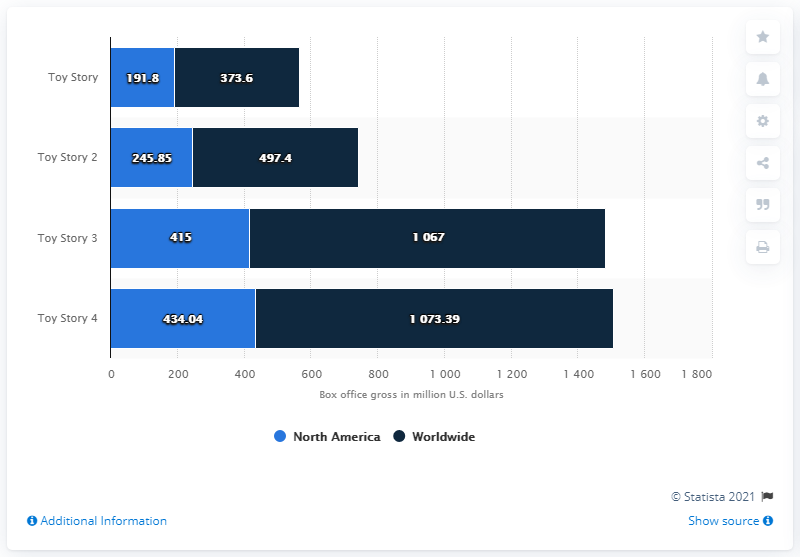Specify some key components in this picture. It is evident that Toy Story 4 has generated the highest box office revenue among all other options. By December 2019, 'Toy Story 4' had generated $434.04 million in domestic box office revenue. The difference between the highest and the lowest revenues in North America is 242.24. 